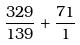Convert formula to latex. <formula><loc_0><loc_0><loc_500><loc_500>\frac { 3 2 9 } { 1 3 9 } + \frac { 7 1 } { 1 }</formula> 